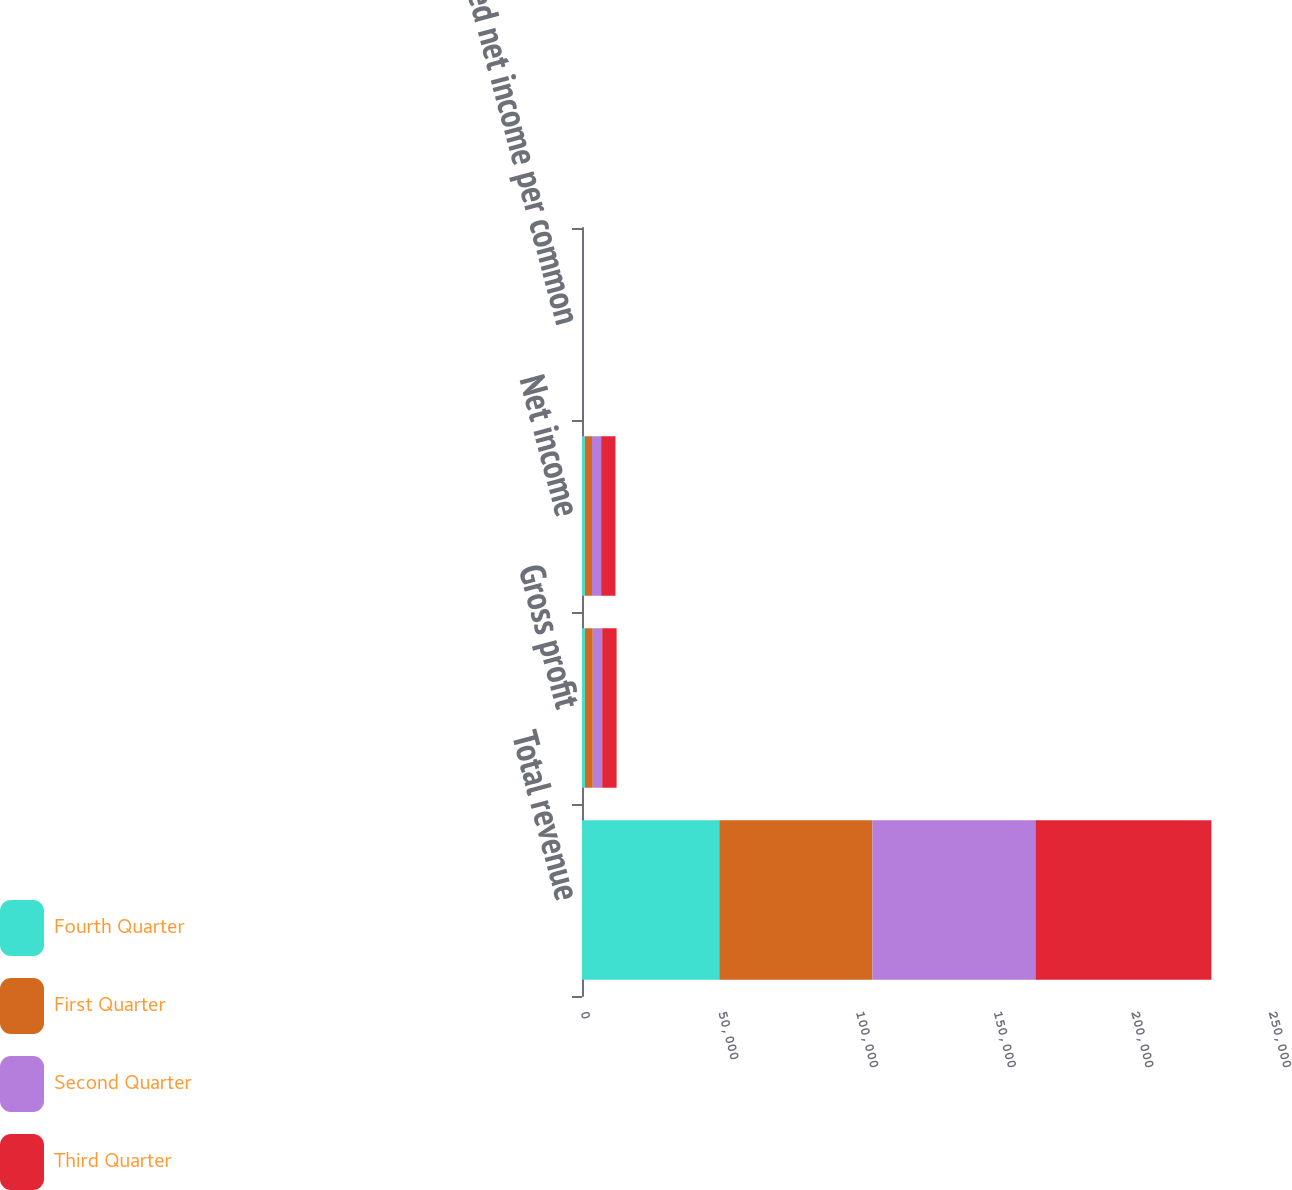Convert chart to OTSL. <chart><loc_0><loc_0><loc_500><loc_500><stacked_bar_chart><ecel><fcel>Total revenue<fcel>Gross profit<fcel>Net income<fcel>Diluted net income per common<nl><fcel>Fourth Quarter<fcel>49882<fcel>1061<fcel>1040<fcel>0.05<nl><fcel>First Quarter<fcel>55648<fcel>2846<fcel>2589<fcel>0.12<nl><fcel>Second Quarter<fcel>59225<fcel>3427<fcel>3325<fcel>0.15<nl><fcel>Third Quarter<fcel>63950<fcel>5252<fcel>5210<fcel>0.24<nl></chart> 